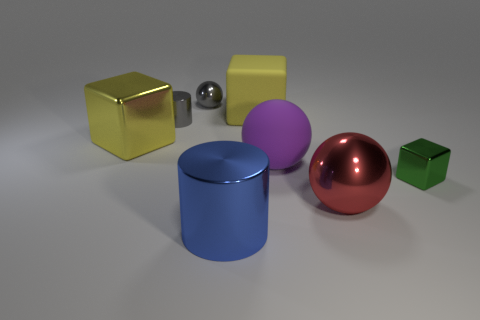Add 2 brown cubes. How many objects exist? 10 Subtract all blocks. How many objects are left? 5 Subtract 0 brown spheres. How many objects are left? 8 Subtract all tiny red matte things. Subtract all tiny metal balls. How many objects are left? 7 Add 6 matte balls. How many matte balls are left? 7 Add 7 shiny spheres. How many shiny spheres exist? 9 